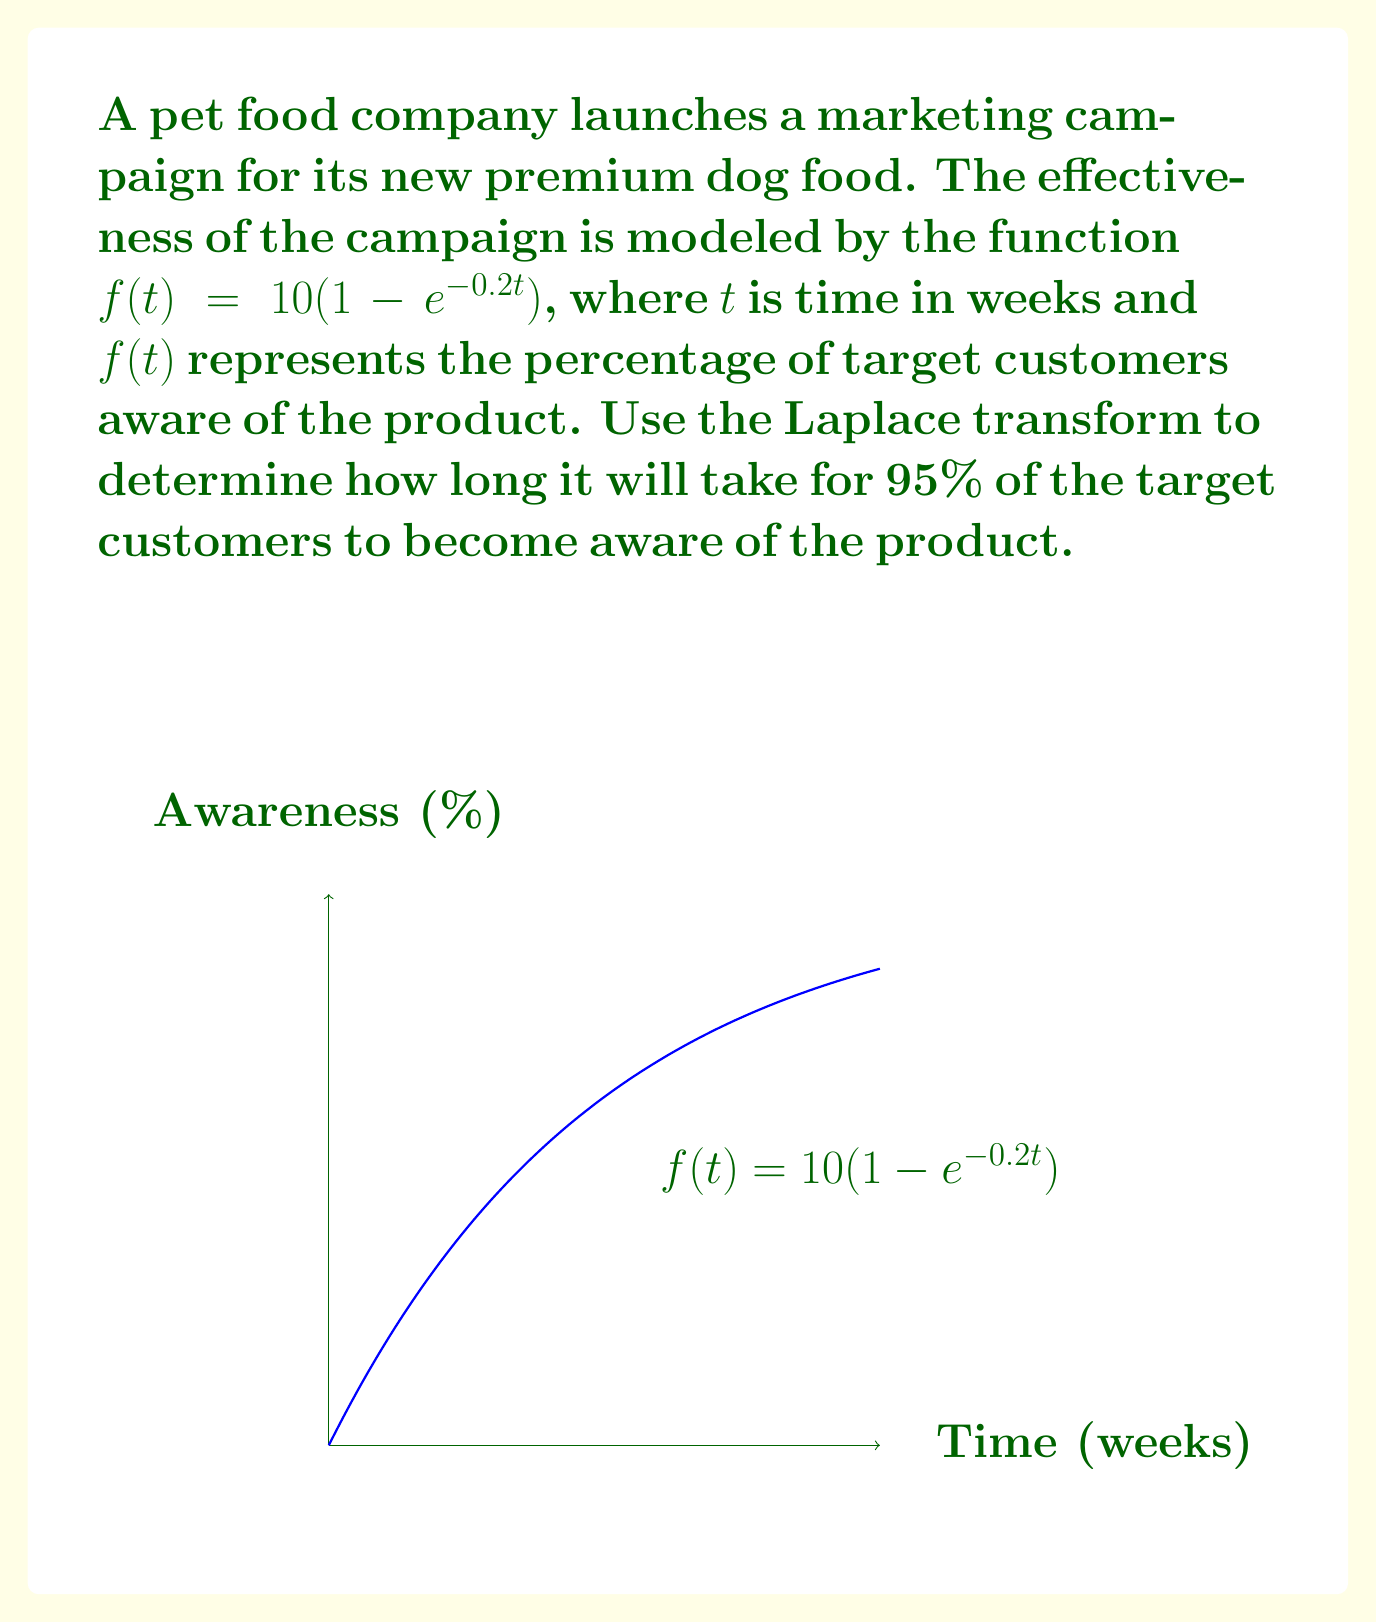Solve this math problem. To solve this problem using Laplace transform, we'll follow these steps:

1) First, we need to find the Laplace transform of $f(t) = 10(1 - e^{-0.2t})$:

   $$\mathcal{L}\{f(t)\} = F(s) = \frac{10}{s} - \frac{10}{s+0.2}$$

2) We want to find when $f(t) = 9.5$ (95% awareness). In the s-domain, this is equivalent to:

   $$\frac{9.5}{s} = \frac{10}{s} - \frac{10}{s+0.2}$$

3) Simplifying:

   $$\frac{9.5}{s} = \frac{10s+2-10s}{s(s+0.2)} = \frac{2}{s(s+0.2)}$$

4) Cross-multiplying:

   $$9.5(s+0.2) = 2$$

5) Solving for s:

   $$s = \frac{2}{9.5} - 0.2 \approx 0.0105$$

6) The final value theorem states that $\lim_{t \to \infty} f(t) = \lim_{s \to 0} sF(s)$. Here, we're looking for a specific value, not the limit as $t$ approaches infinity. We can use the initial value theorem in reverse:

   $$f(t) = 9.5 \Leftrightarrow s = 0.0105$$

7) The time domain function corresponding to $\frac{1}{s-a}$ is $e^{at}$. Therefore, the time $t$ when awareness reaches 95% is:

   $$t = -\frac{\ln(0.0105)}{0.0105} \approx 14.98 \text{ weeks}$$
Answer: $14.98$ weeks 